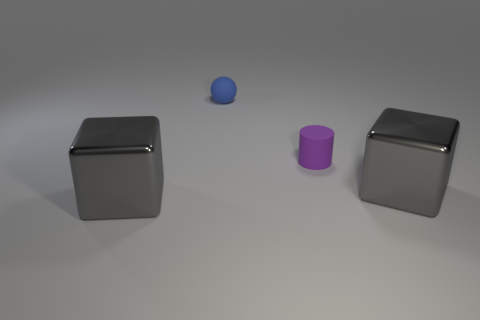Add 2 gray shiny blocks. How many objects exist? 6 Add 2 purple cylinders. How many purple cylinders exist? 3 Subtract 0 yellow balls. How many objects are left? 4 Subtract all things. Subtract all small brown matte spheres. How many objects are left? 0 Add 4 gray objects. How many gray objects are left? 6 